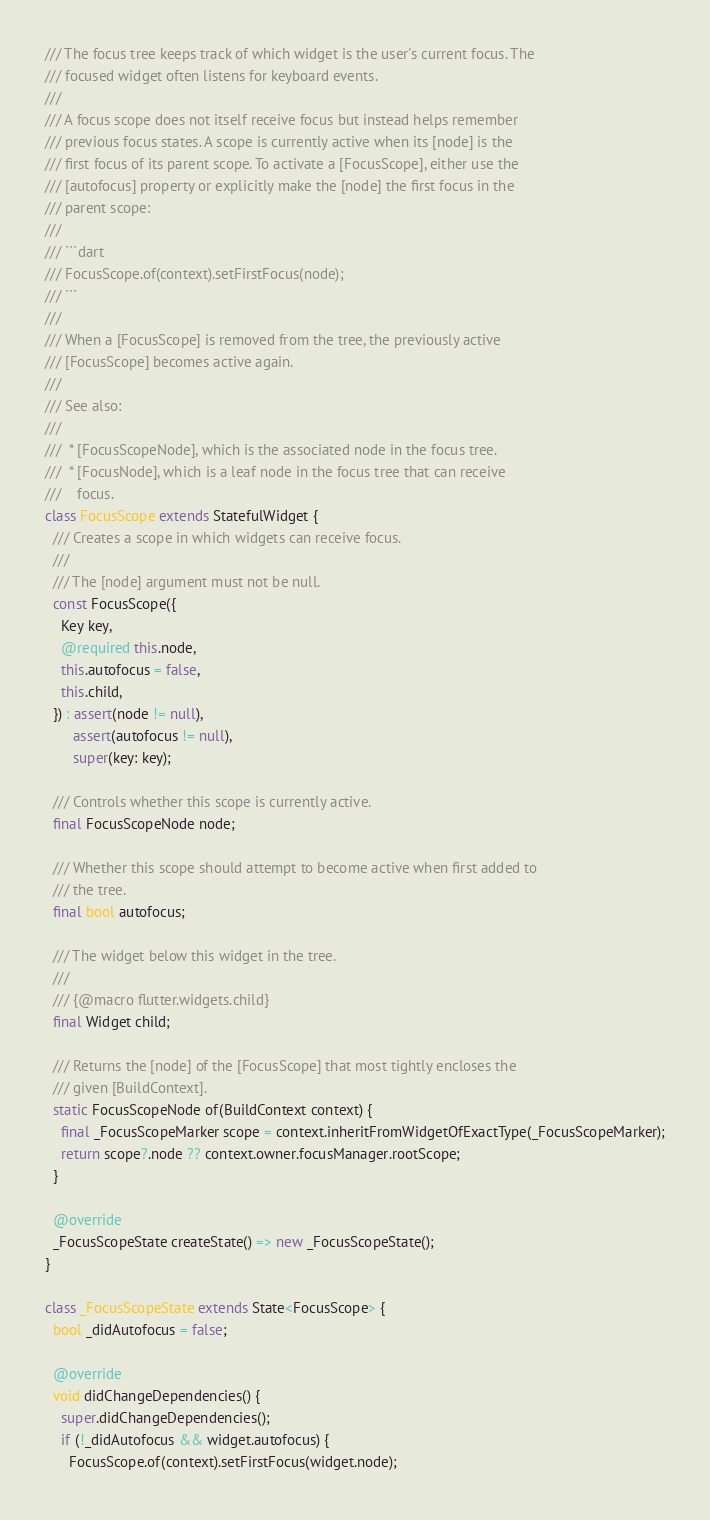<code> <loc_0><loc_0><loc_500><loc_500><_Dart_>/// The focus tree keeps track of which widget is the user's current focus. The
/// focused widget often listens for keyboard events.
///
/// A focus scope does not itself receive focus but instead helps remember
/// previous focus states. A scope is currently active when its [node] is the
/// first focus of its parent scope. To activate a [FocusScope], either use the
/// [autofocus] property or explicitly make the [node] the first focus in the
/// parent scope:
///
/// ```dart
/// FocusScope.of(context).setFirstFocus(node);
/// ```
///
/// When a [FocusScope] is removed from the tree, the previously active
/// [FocusScope] becomes active again.
///
/// See also:
///
///  * [FocusScopeNode], which is the associated node in the focus tree.
///  * [FocusNode], which is a leaf node in the focus tree that can receive
///    focus.
class FocusScope extends StatefulWidget {
  /// Creates a scope in which widgets can receive focus.
  ///
  /// The [node] argument must not be null.
  const FocusScope({
    Key key,
    @required this.node,
    this.autofocus = false,
    this.child,
  }) : assert(node != null),
       assert(autofocus != null),
       super(key: key);

  /// Controls whether this scope is currently active.
  final FocusScopeNode node;

  /// Whether this scope should attempt to become active when first added to
  /// the tree.
  final bool autofocus;

  /// The widget below this widget in the tree.
  ///
  /// {@macro flutter.widgets.child}
  final Widget child;

  /// Returns the [node] of the [FocusScope] that most tightly encloses the
  /// given [BuildContext].
  static FocusScopeNode of(BuildContext context) {
    final _FocusScopeMarker scope = context.inheritFromWidgetOfExactType(_FocusScopeMarker);
    return scope?.node ?? context.owner.focusManager.rootScope;
  }

  @override
  _FocusScopeState createState() => new _FocusScopeState();
}

class _FocusScopeState extends State<FocusScope> {
  bool _didAutofocus = false;

  @override
  void didChangeDependencies() {
    super.didChangeDependencies();
    if (!_didAutofocus && widget.autofocus) {
      FocusScope.of(context).setFirstFocus(widget.node);</code> 